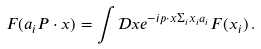Convert formula to latex. <formula><loc_0><loc_0><loc_500><loc_500>F ( a _ { i } P \cdot x ) = \int \mathcal { D } x e ^ { - i p \cdot x \Sigma _ { i } x _ { i } a _ { i } } F ( x _ { i } ) \, .</formula> 